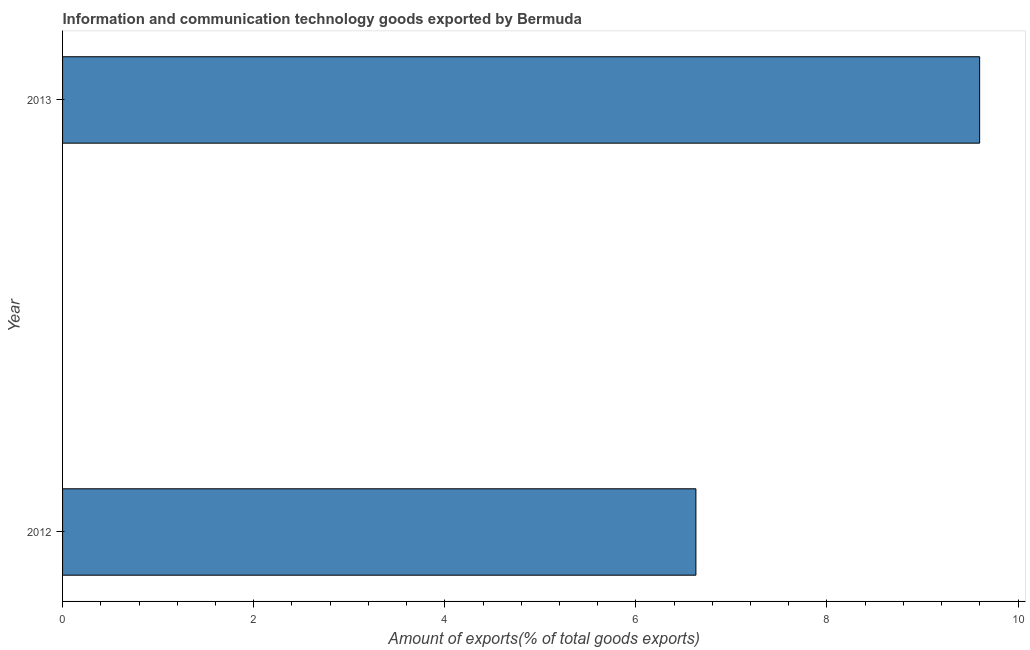Does the graph contain any zero values?
Provide a succinct answer. No. Does the graph contain grids?
Offer a very short reply. No. What is the title of the graph?
Offer a very short reply. Information and communication technology goods exported by Bermuda. What is the label or title of the X-axis?
Make the answer very short. Amount of exports(% of total goods exports). What is the label or title of the Y-axis?
Provide a short and direct response. Year. What is the amount of ict goods exports in 2012?
Keep it short and to the point. 6.63. Across all years, what is the maximum amount of ict goods exports?
Your answer should be compact. 9.6. Across all years, what is the minimum amount of ict goods exports?
Your answer should be compact. 6.63. In which year was the amount of ict goods exports maximum?
Ensure brevity in your answer.  2013. In which year was the amount of ict goods exports minimum?
Provide a succinct answer. 2012. What is the sum of the amount of ict goods exports?
Offer a terse response. 16.23. What is the difference between the amount of ict goods exports in 2012 and 2013?
Your answer should be very brief. -2.97. What is the average amount of ict goods exports per year?
Your answer should be very brief. 8.11. What is the median amount of ict goods exports?
Keep it short and to the point. 8.11. In how many years, is the amount of ict goods exports greater than 6.4 %?
Provide a short and direct response. 2. Do a majority of the years between 2013 and 2012 (inclusive) have amount of ict goods exports greater than 6.8 %?
Your answer should be compact. No. What is the ratio of the amount of ict goods exports in 2012 to that in 2013?
Provide a succinct answer. 0.69. Is the amount of ict goods exports in 2012 less than that in 2013?
Provide a succinct answer. Yes. In how many years, is the amount of ict goods exports greater than the average amount of ict goods exports taken over all years?
Offer a terse response. 1. Are all the bars in the graph horizontal?
Offer a very short reply. Yes. How many years are there in the graph?
Make the answer very short. 2. Are the values on the major ticks of X-axis written in scientific E-notation?
Your answer should be compact. No. What is the Amount of exports(% of total goods exports) of 2012?
Provide a short and direct response. 6.63. What is the Amount of exports(% of total goods exports) in 2013?
Your answer should be very brief. 9.6. What is the difference between the Amount of exports(% of total goods exports) in 2012 and 2013?
Your answer should be compact. -2.97. What is the ratio of the Amount of exports(% of total goods exports) in 2012 to that in 2013?
Provide a succinct answer. 0.69. 